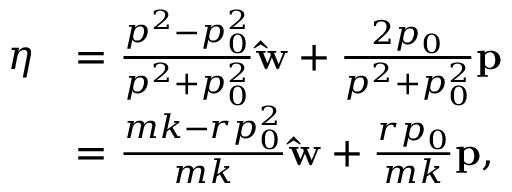Convert formula to latex. <formula><loc_0><loc_0><loc_500><loc_500>{ \begin{array} { r l } { \eta } & { = { \frac { p ^ { 2 } - p _ { 0 } ^ { 2 } } { p ^ { 2 } + p _ { 0 } ^ { 2 } } } \hat { w } + { \frac { 2 p _ { 0 } } { p ^ { 2 } + p _ { 0 } ^ { 2 } } } p } \\ & { = { \frac { m k - r p _ { 0 } ^ { 2 } } { m k } } \hat { w } + { \frac { r p _ { 0 } } { m k } } p , } \end{array} }</formula> 